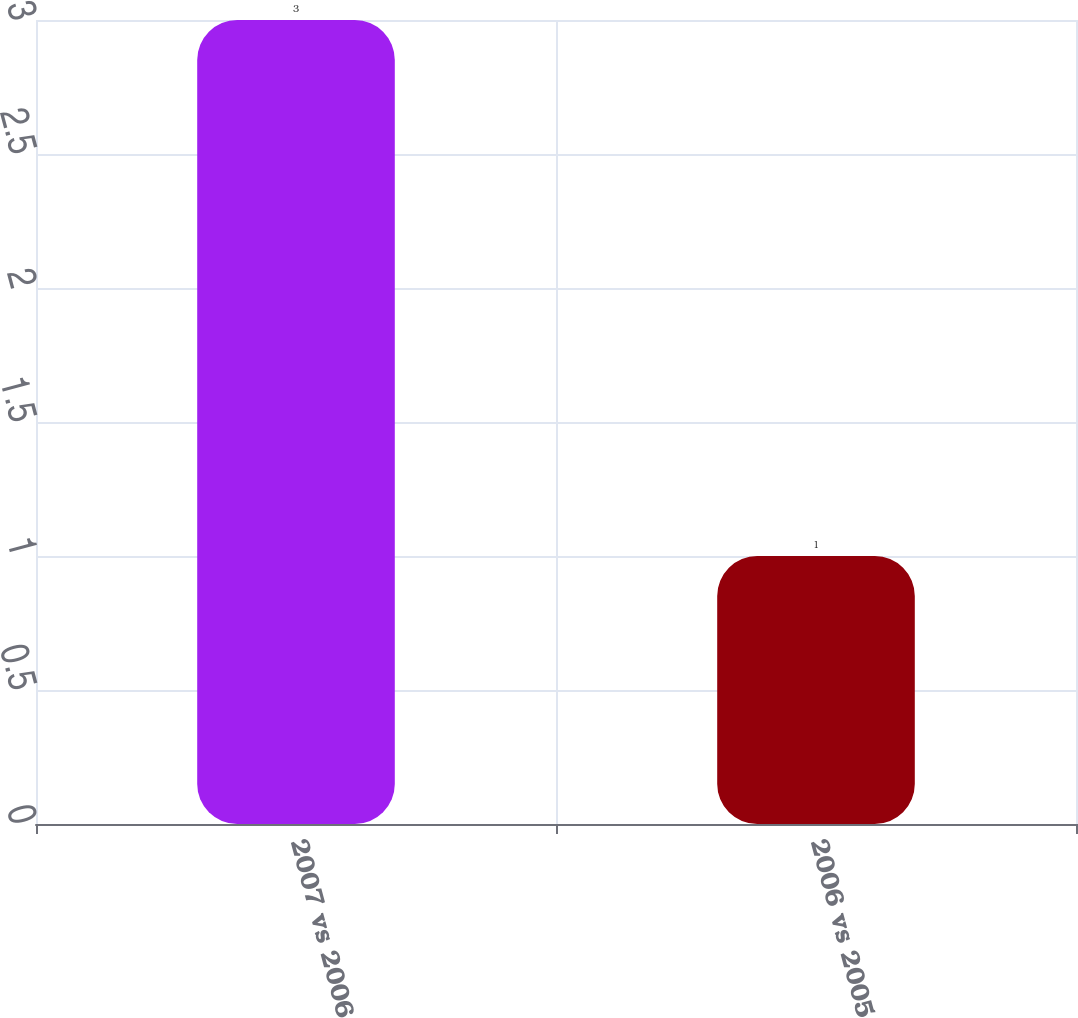Convert chart. <chart><loc_0><loc_0><loc_500><loc_500><bar_chart><fcel>2007 vs 2006<fcel>2006 vs 2005<nl><fcel>3<fcel>1<nl></chart> 